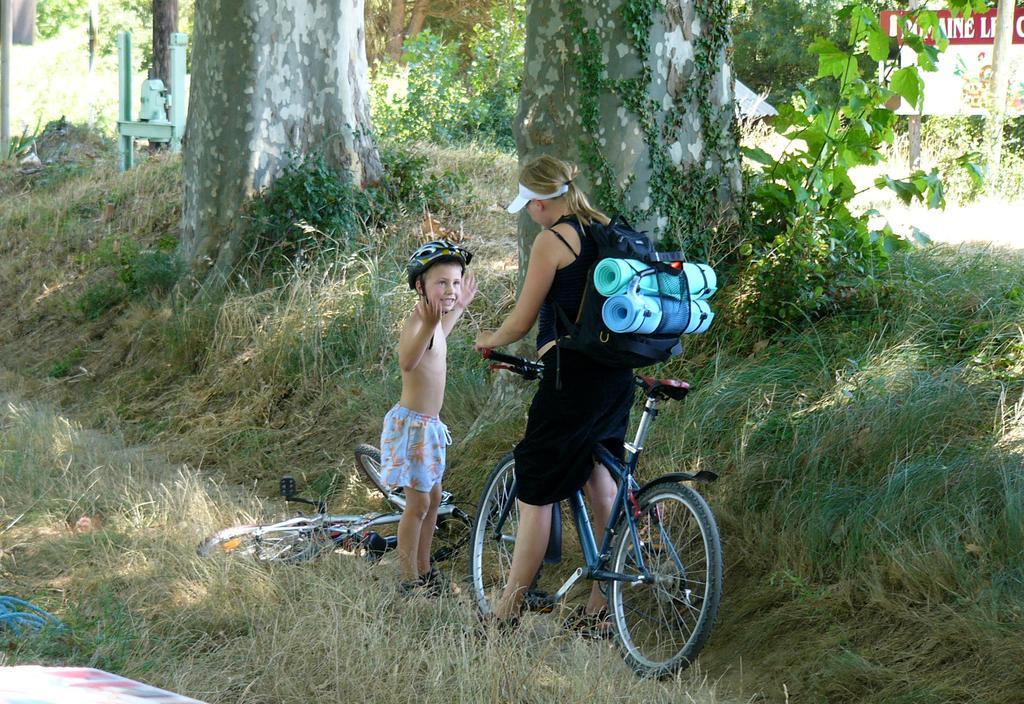How would you summarize this image in a sentence or two? This picture shows a women on a bicycle and the another boy who is wearing a helmet and there is another bicycle on the ground and in the background there are trees and grass. 